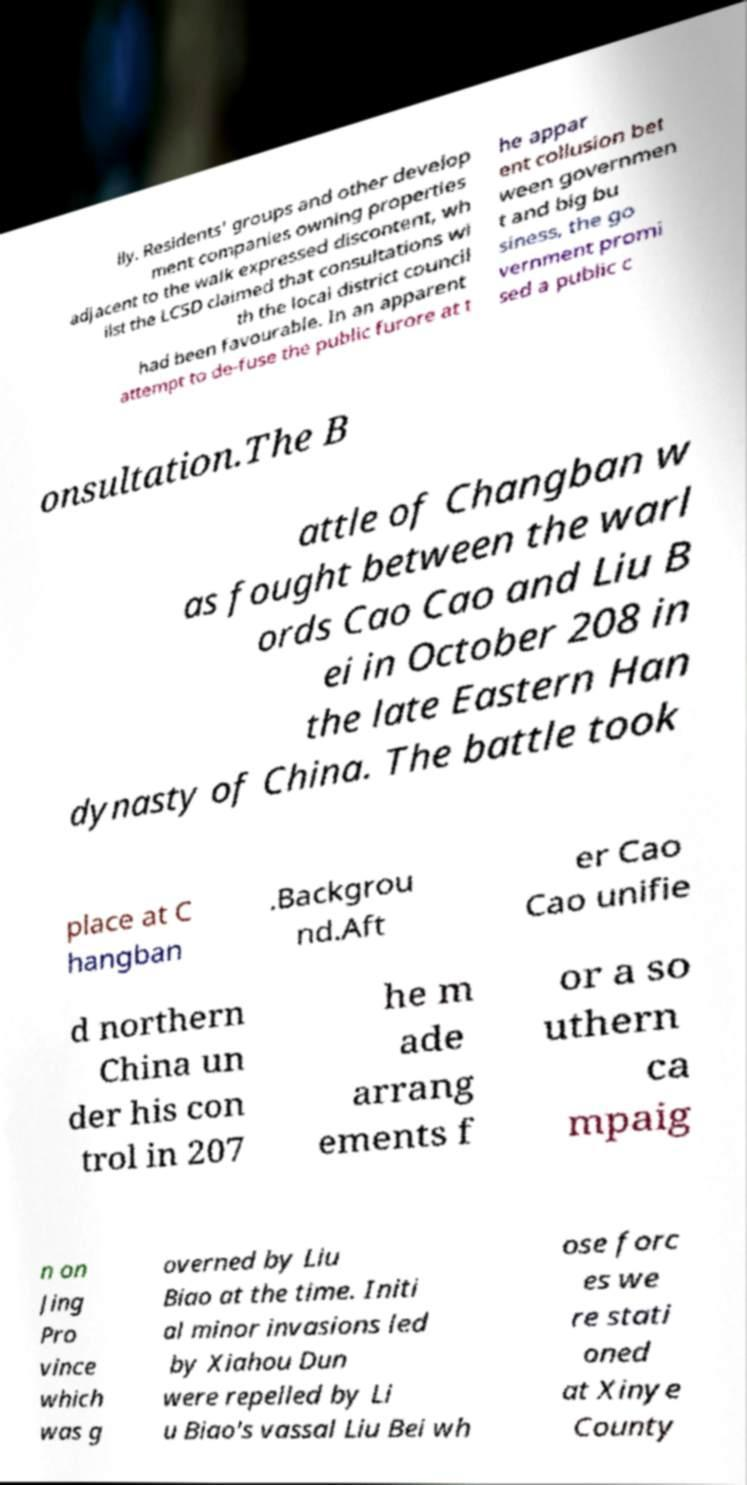Could you assist in decoding the text presented in this image and type it out clearly? lly. Residents' groups and other develop ment companies owning properties adjacent to the walk expressed discontent, wh ilst the LCSD claimed that consultations wi th the local district council had been favourable. In an apparent attempt to de-fuse the public furore at t he appar ent collusion bet ween governmen t and big bu siness, the go vernment promi sed a public c onsultation.The B attle of Changban w as fought between the warl ords Cao Cao and Liu B ei in October 208 in the late Eastern Han dynasty of China. The battle took place at C hangban .Backgrou nd.Aft er Cao Cao unifie d northern China un der his con trol in 207 he m ade arrang ements f or a so uthern ca mpaig n on Jing Pro vince which was g overned by Liu Biao at the time. Initi al minor invasions led by Xiahou Dun were repelled by Li u Biao's vassal Liu Bei wh ose forc es we re stati oned at Xinye County 